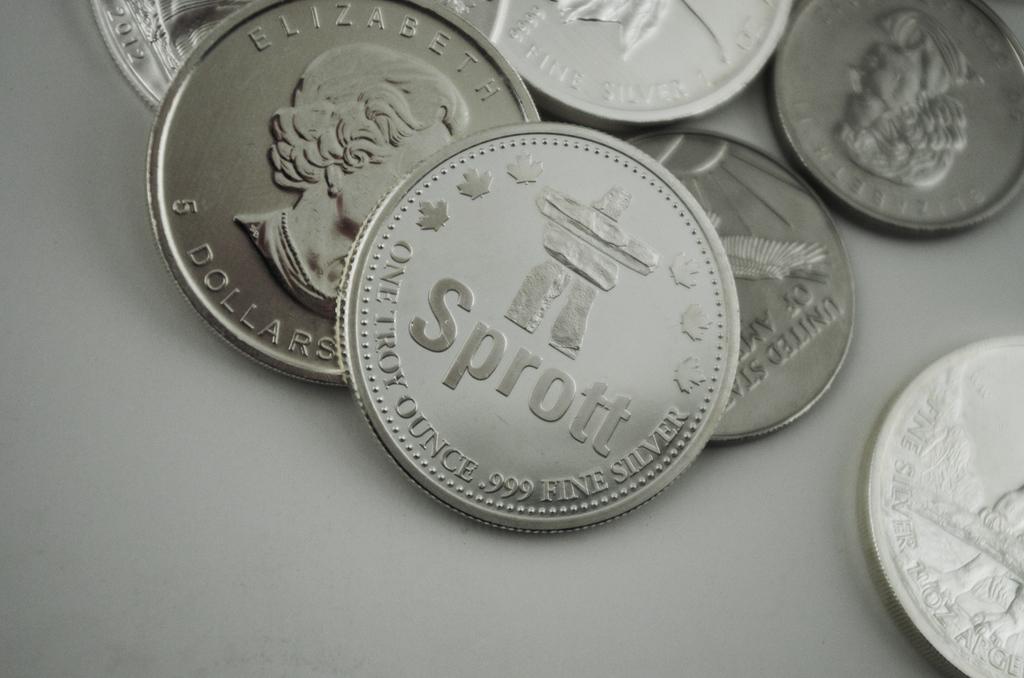Which queen is on these coins?
Keep it short and to the point. Elizabeth. How much is this coin worth?
Offer a very short reply. 5 dollars. 